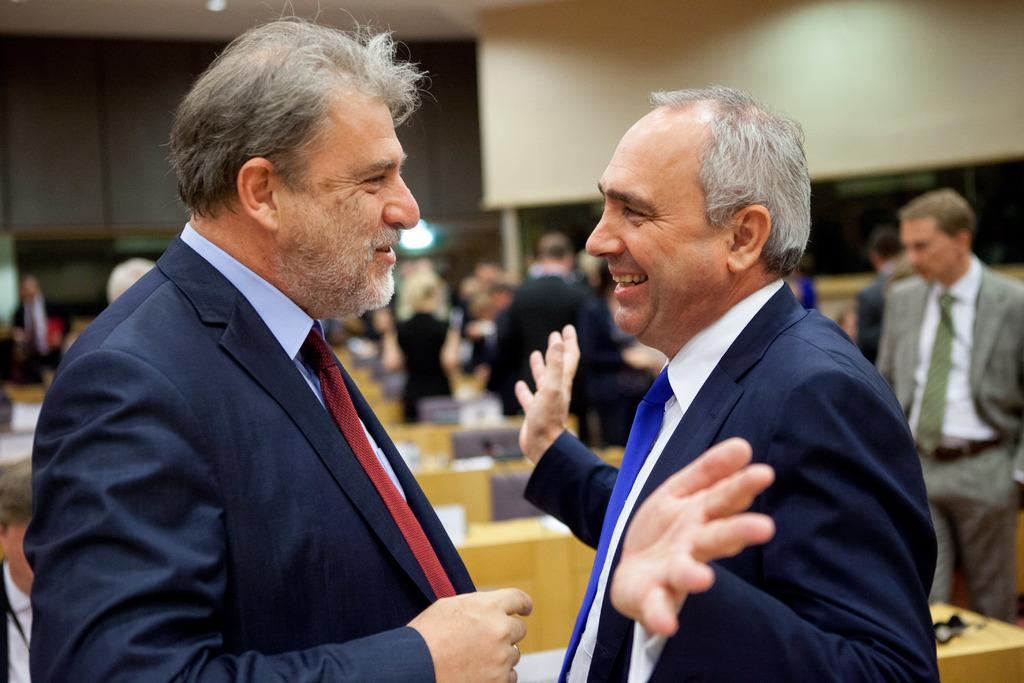How many people are in the image? There are two men in the image. What are the men doing in the image? The men are talking to each other. What else can be seen in the image besides the men? There are tables visible in the image. Are there any other people present in the image? Yes, there are other people in the image. What color is the hydrant near the men in the image? There is no hydrant present in the image. How old is the boy sitting at the table in the image? There is no boy present in the image. 